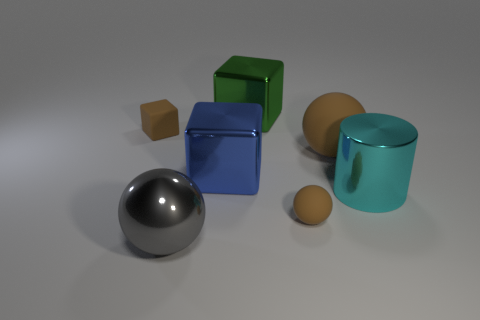Is the material of the tiny brown thing that is in front of the cyan metal object the same as the tiny brown thing that is behind the big brown rubber thing? Based on visual assessment, both tiny brown objects appear to be of similar material, likely resembling wood or a wood-like texture. It's not possible to determine the exact material without additional context or sensory information, but given that they are of matching color and finish, they seem to be the same or very similar materials. 